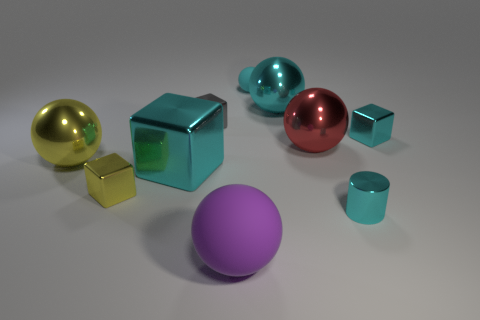Subtract 1 balls. How many balls are left? 4 Subtract all big cyan metal spheres. How many spheres are left? 4 Subtract all purple balls. How many balls are left? 4 Subtract all blue spheres. Subtract all gray cylinders. How many spheres are left? 5 Subtract all blocks. How many objects are left? 6 Subtract all big yellow metal balls. Subtract all tiny yellow cubes. How many objects are left? 8 Add 4 small cyan cylinders. How many small cyan cylinders are left? 5 Add 5 cyan spheres. How many cyan spheres exist? 7 Subtract 1 cyan cubes. How many objects are left? 9 